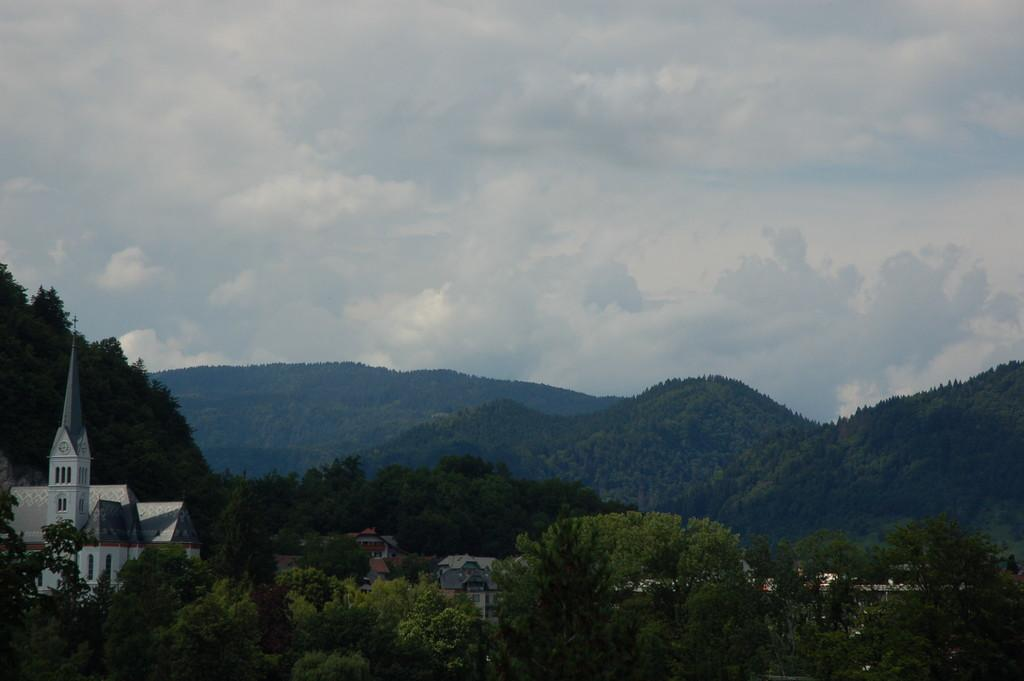What type of structure is present in the image? There is a building in the image. What other types of structures are present in the image? There are houses in the image. What can be seen around the houses and buildings? There are many trees around the houses and buildings. What is visible in the background of the image? Mountains, clouds, and the sky are visible in the background of the image. What verse can be heard recited by the giraffe in the image? There is no giraffe present in the image, and therefore no verse can be heard. 